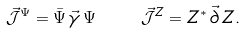<formula> <loc_0><loc_0><loc_500><loc_500>\vec { \mathcal { J } } ^ { \Psi } = \bar { \Psi } \, \vec { \gamma } \, \Psi \quad \vec { \mathcal { J } } ^ { Z } = Z ^ { * } \, \vec { \partial } \, Z .</formula> 